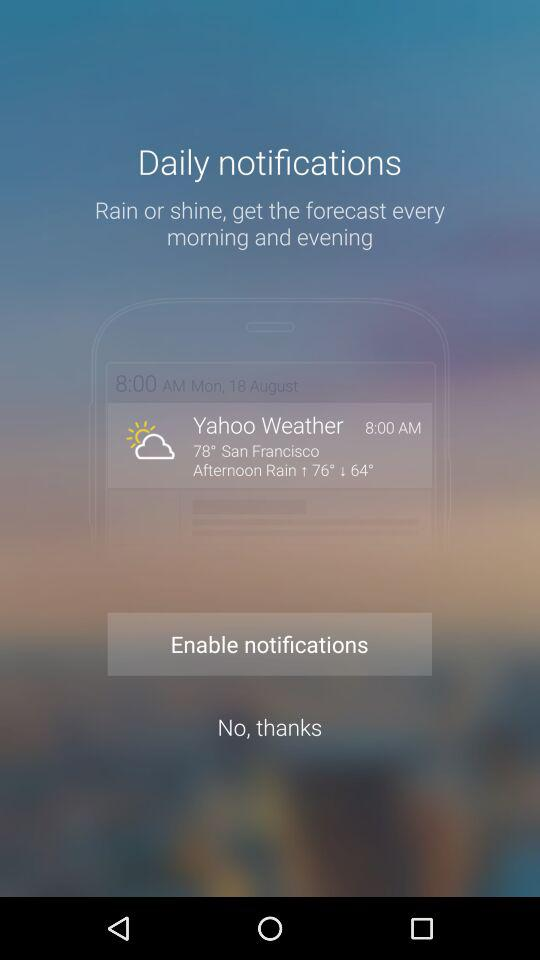What is the time and date? The time and the date are 8:00 AM and Monday, August 18th. 